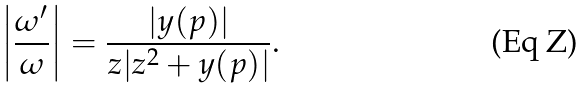<formula> <loc_0><loc_0><loc_500><loc_500>\left | \frac { \omega ^ { \prime } } { \omega } \right | = \frac { | y ( p ) | } { z | z ^ { 2 } + y ( p ) | } .</formula> 